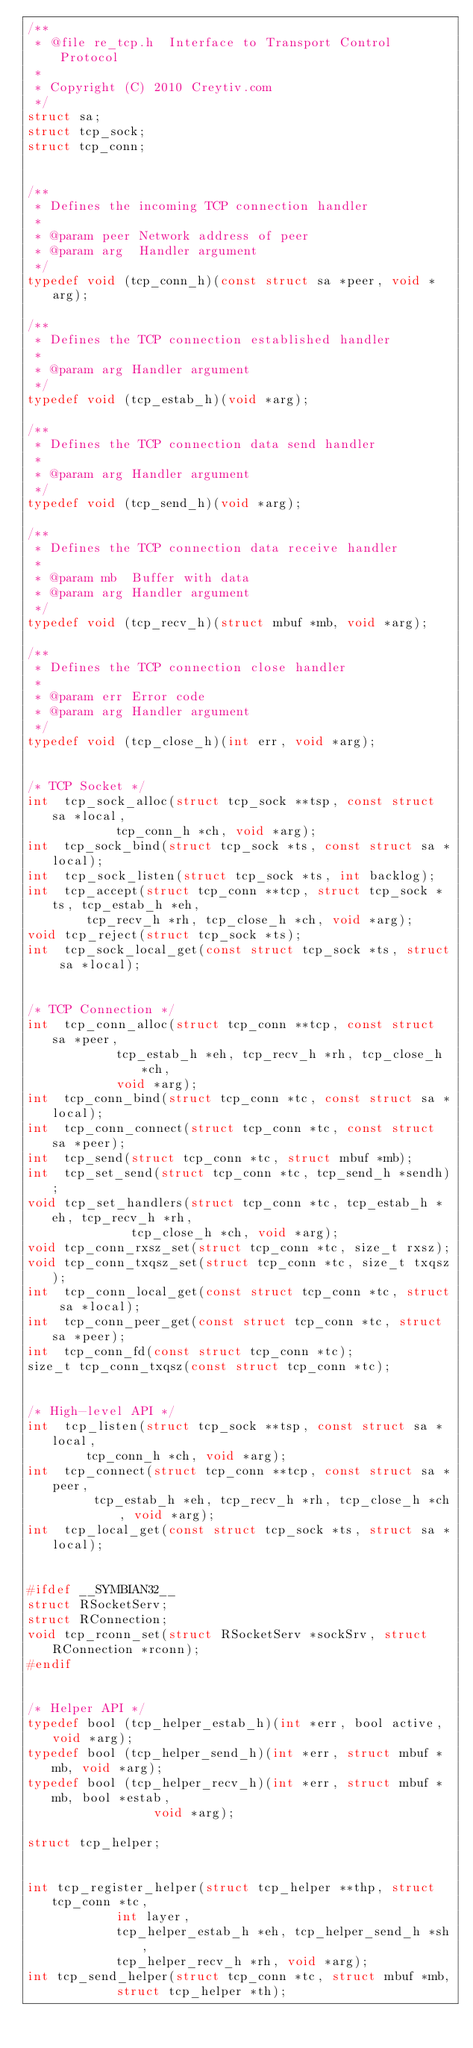Convert code to text. <code><loc_0><loc_0><loc_500><loc_500><_C_>/**
 * @file re_tcp.h  Interface to Transport Control Protocol
 *
 * Copyright (C) 2010 Creytiv.com
 */
struct sa;
struct tcp_sock;
struct tcp_conn;


/**
 * Defines the incoming TCP connection handler
 *
 * @param peer Network address of peer
 * @param arg  Handler argument
 */
typedef void (tcp_conn_h)(const struct sa *peer, void *arg);

/**
 * Defines the TCP connection established handler
 *
 * @param arg Handler argument
 */
typedef void (tcp_estab_h)(void *arg);

/**
 * Defines the TCP connection data send handler
 *
 * @param arg Handler argument
 */
typedef void (tcp_send_h)(void *arg);

/**
 * Defines the TCP connection data receive handler
 *
 * @param mb  Buffer with data
 * @param arg Handler argument
 */
typedef void (tcp_recv_h)(struct mbuf *mb, void *arg);

/**
 * Defines the TCP connection close handler
 *
 * @param err Error code
 * @param arg Handler argument
 */
typedef void (tcp_close_h)(int err, void *arg);


/* TCP Socket */
int  tcp_sock_alloc(struct tcp_sock **tsp, const struct sa *local,
		    tcp_conn_h *ch, void *arg);
int  tcp_sock_bind(struct tcp_sock *ts, const struct sa *local);
int  tcp_sock_listen(struct tcp_sock *ts, int backlog);
int  tcp_accept(struct tcp_conn **tcp, struct tcp_sock *ts, tcp_estab_h *eh,
		tcp_recv_h *rh, tcp_close_h *ch, void *arg);
void tcp_reject(struct tcp_sock *ts);
int  tcp_sock_local_get(const struct tcp_sock *ts, struct sa *local);


/* TCP Connection */
int  tcp_conn_alloc(struct tcp_conn **tcp, const struct sa *peer,
		    tcp_estab_h *eh, tcp_recv_h *rh, tcp_close_h *ch,
		    void *arg);
int  tcp_conn_bind(struct tcp_conn *tc, const struct sa *local);
int  tcp_conn_connect(struct tcp_conn *tc, const struct sa *peer);
int  tcp_send(struct tcp_conn *tc, struct mbuf *mb);
int  tcp_set_send(struct tcp_conn *tc, tcp_send_h *sendh);
void tcp_set_handlers(struct tcp_conn *tc, tcp_estab_h *eh, tcp_recv_h *rh,
		      tcp_close_h *ch, void *arg);
void tcp_conn_rxsz_set(struct tcp_conn *tc, size_t rxsz);
void tcp_conn_txqsz_set(struct tcp_conn *tc, size_t txqsz);
int  tcp_conn_local_get(const struct tcp_conn *tc, struct sa *local);
int  tcp_conn_peer_get(const struct tcp_conn *tc, struct sa *peer);
int  tcp_conn_fd(const struct tcp_conn *tc);
size_t tcp_conn_txqsz(const struct tcp_conn *tc);


/* High-level API */
int  tcp_listen(struct tcp_sock **tsp, const struct sa *local,
		tcp_conn_h *ch, void *arg);
int  tcp_connect(struct tcp_conn **tcp, const struct sa *peer,
		 tcp_estab_h *eh, tcp_recv_h *rh, tcp_close_h *ch, void *arg);
int  tcp_local_get(const struct tcp_sock *ts, struct sa *local);


#ifdef __SYMBIAN32__
struct RSocketServ;
struct RConnection;
void tcp_rconn_set(struct RSocketServ *sockSrv, struct RConnection *rconn);
#endif


/* Helper API */
typedef bool (tcp_helper_estab_h)(int *err, bool active, void *arg);
typedef bool (tcp_helper_send_h)(int *err, struct mbuf *mb, void *arg);
typedef bool (tcp_helper_recv_h)(int *err, struct mbuf *mb, bool *estab,
				 void *arg);

struct tcp_helper;


int tcp_register_helper(struct tcp_helper **thp, struct tcp_conn *tc,
			int layer,
			tcp_helper_estab_h *eh, tcp_helper_send_h *sh,
			tcp_helper_recv_h *rh, void *arg);
int tcp_send_helper(struct tcp_conn *tc, struct mbuf *mb,
		    struct tcp_helper *th);
</code> 